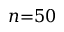Convert formula to latex. <formula><loc_0><loc_0><loc_500><loc_500>n { = } 5 0</formula> 